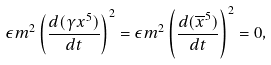Convert formula to latex. <formula><loc_0><loc_0><loc_500><loc_500>\epsilon m ^ { 2 } \left ( \frac { d ( \gamma x ^ { 5 } ) } { d t } \right ) ^ { 2 } = \epsilon m ^ { 2 } \left ( \frac { d ( \overline { x } ^ { 5 } ) } { d t } \right ) ^ { 2 } = 0 ,</formula> 